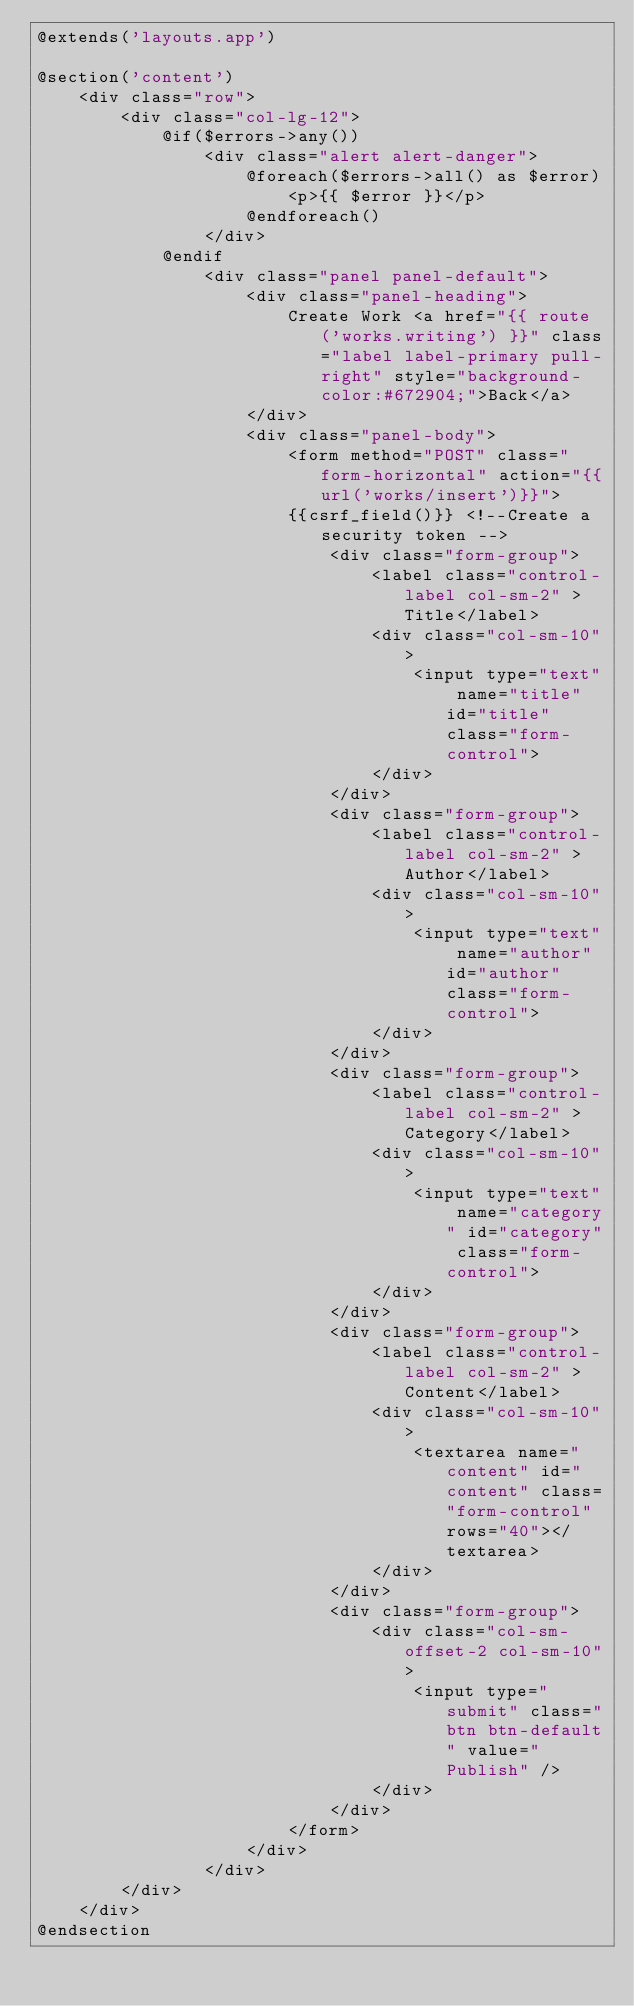<code> <loc_0><loc_0><loc_500><loc_500><_PHP_>@extends('layouts.app')

@section('content')
    <div class="row">
        <div class="col-lg-12">
            @if($errors->any())
                <div class="alert alert-danger">
                    @foreach($errors->all() as $error)
                        <p>{{ $error }}</p>
                    @endforeach()
                </div>
            @endif
                <div class="panel panel-default">
                    <div class="panel-heading">
                        Create Work <a href="{{ route('works.writing') }}" class="label label-primary pull-right" style="background-color:#672904;">Back</a>
                    </div>
                    <div class="panel-body">
                        <form method="POST" class="form-horizontal" action="{{url('works/insert')}}">
                        {{csrf_field()}} <!--Create a security token -->
                            <div class="form-group">
                                <label class="control-label col-sm-2" >Title</label>
                                <div class="col-sm-10">
                                    <input type="text" name="title" id="title" class="form-control">
                                </div>
                            </div>
                            <div class="form-group">
                                <label class="control-label col-sm-2" >Author</label>
                                <div class="col-sm-10">
                                    <input type="text" name="author" id="author" class="form-control">
                                </div>
                            </div>
                            <div class="form-group">
                                <label class="control-label col-sm-2" >Category</label>
                                <div class="col-sm-10">
                                    <input type="text" name="category" id="category" class="form-control">
                                </div>
                            </div>
                            <div class="form-group">
                                <label class="control-label col-sm-2" >Content</label>
                                <div class="col-sm-10">
                                    <textarea name="content" id="content" class="form-control" rows="40"></textarea>
                                </div>
                            </div>
                            <div class="form-group">
                                <div class="col-sm-offset-2 col-sm-10">
                                    <input type="submit" class="btn btn-default" value="Publish" />
                                </div>
                            </div>
                        </form>
                    </div>
                </div>
        </div>
    </div>
@endsection</code> 